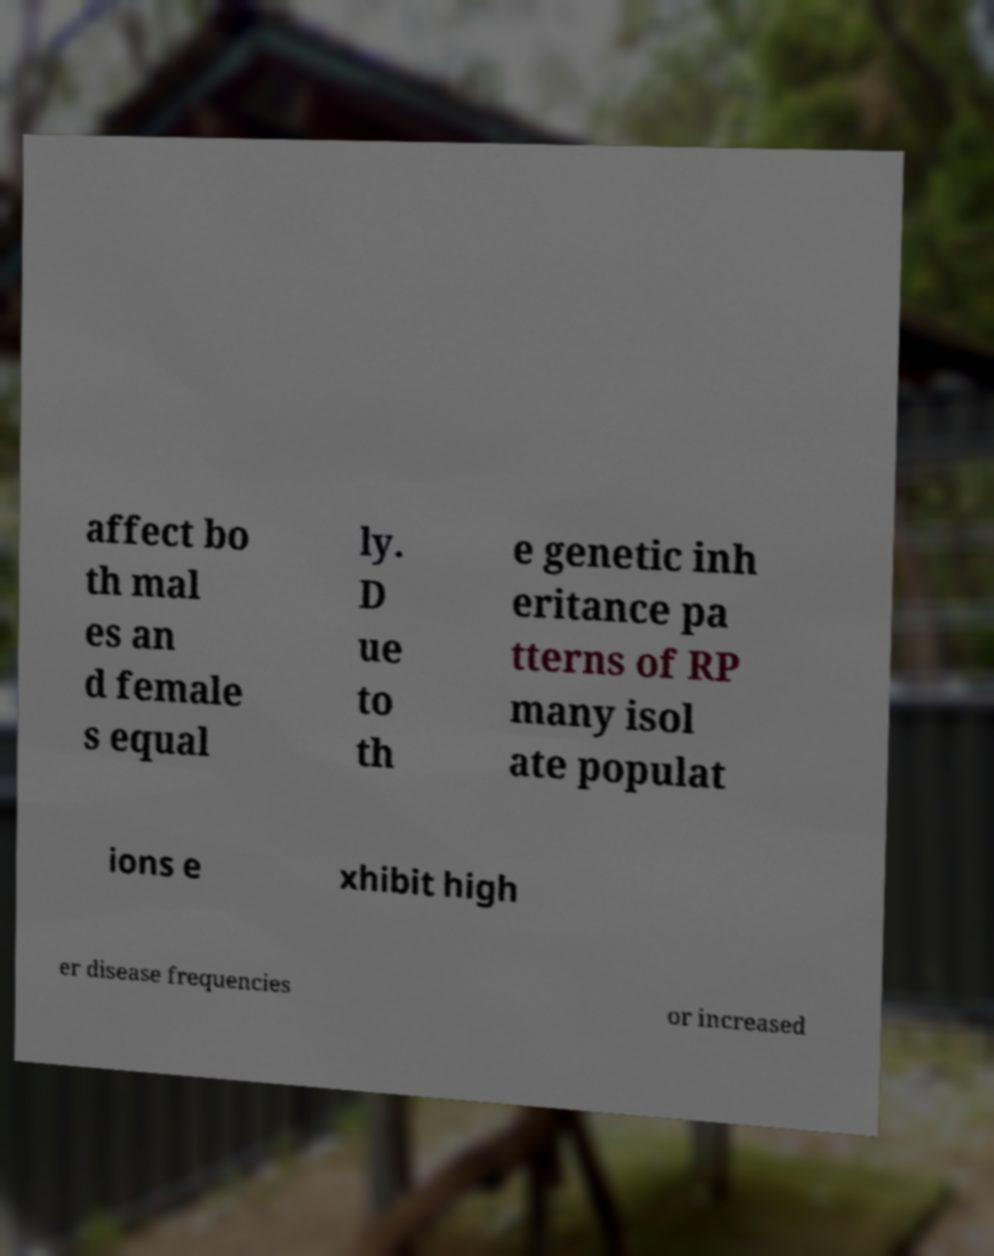What messages or text are displayed in this image? I need them in a readable, typed format. affect bo th mal es an d female s equal ly. D ue to th e genetic inh eritance pa tterns of RP many isol ate populat ions e xhibit high er disease frequencies or increased 